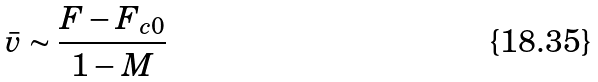Convert formula to latex. <formula><loc_0><loc_0><loc_500><loc_500>\bar { v } \sim \frac { F - F _ { c 0 } } { 1 - M }</formula> 